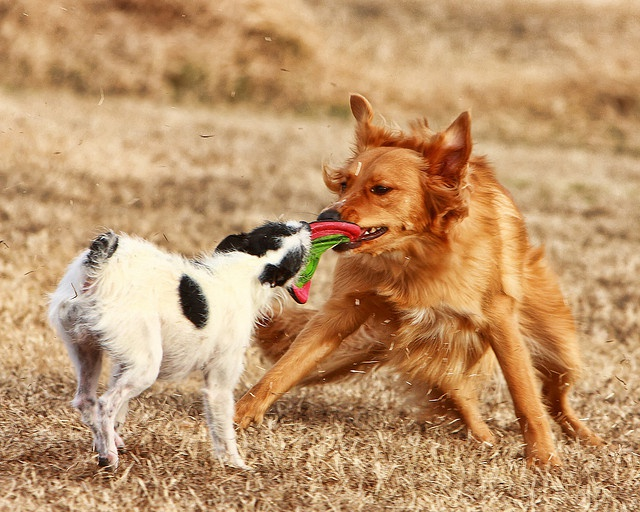Describe the objects in this image and their specific colors. I can see dog in tan, brown, and maroon tones, dog in tan, beige, black, and darkgray tones, and frisbee in tan, olive, salmon, and brown tones in this image. 